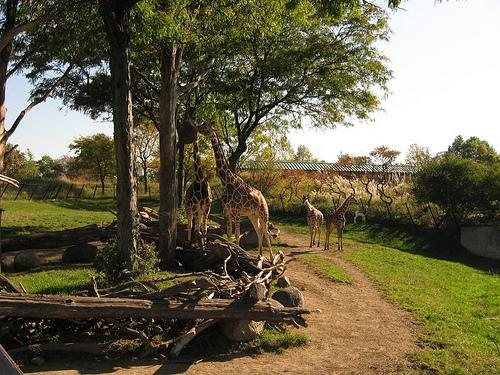Protected areas for these types of animals are known as what? sanctuary 